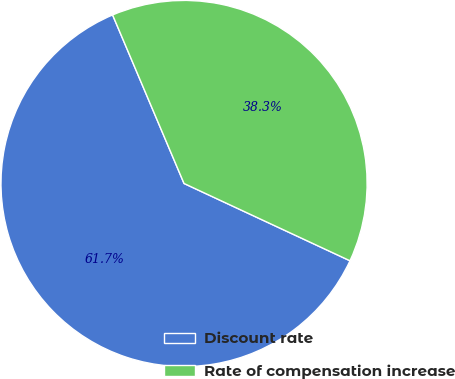Convert chart. <chart><loc_0><loc_0><loc_500><loc_500><pie_chart><fcel>Discount rate<fcel>Rate of compensation increase<nl><fcel>61.68%<fcel>38.32%<nl></chart> 